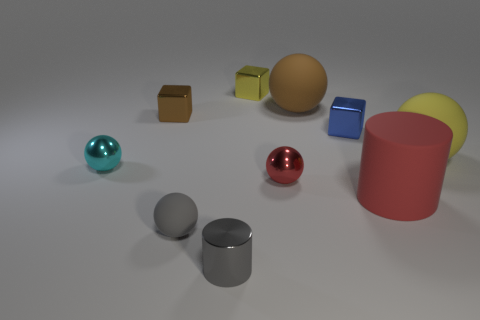Subtract all gray rubber balls. How many balls are left? 4 Subtract all red cylinders. How many cylinders are left? 1 Subtract all cylinders. How many objects are left? 8 Add 1 cyan shiny balls. How many cyan shiny balls exist? 2 Subtract 1 red balls. How many objects are left? 9 Subtract 2 balls. How many balls are left? 3 Subtract all purple balls. Subtract all blue blocks. How many balls are left? 5 Subtract all small cyan metal cubes. Subtract all tiny yellow metallic objects. How many objects are left? 9 Add 4 blue metallic objects. How many blue metallic objects are left? 5 